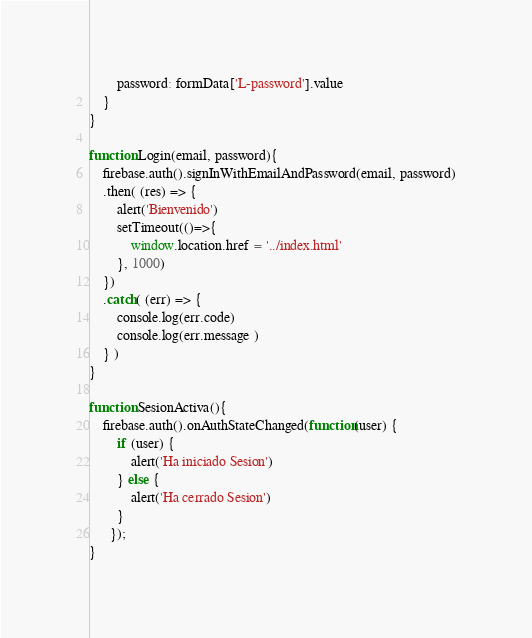<code> <loc_0><loc_0><loc_500><loc_500><_JavaScript_>        password: formData['L-password'].value
    }
}

function Login(email, password){
    firebase.auth().signInWithEmailAndPassword(email, password)
    .then( (res) => {
        alert('Bienvenido')
        setTimeout(()=>{
            window.location.href = '../index.html'
        }, 1000)
    })
    .catch( (err) => {
        console.log(err.code)
        console.log(err.message )
    } )
}

function SesionActiva(){
    firebase.auth().onAuthStateChanged(function(user) {
        if (user) {
            alert('Ha iniciado Sesion')
        } else {
            alert('Ha cerrado Sesion')
        }
      });    
}

</code> 